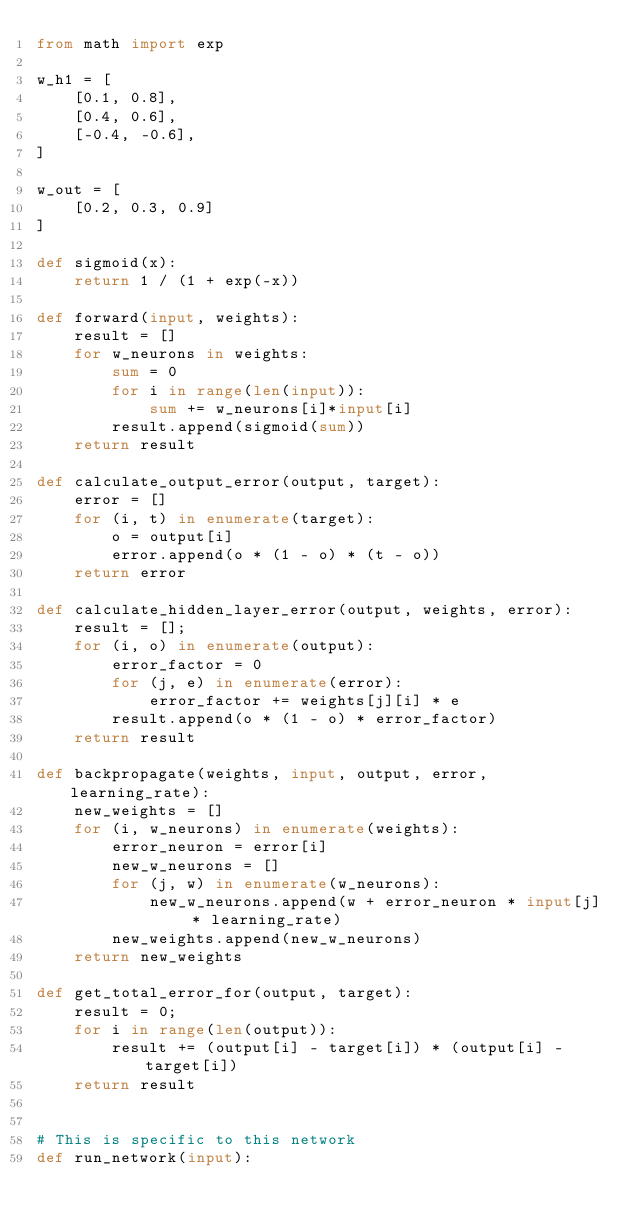Convert code to text. <code><loc_0><loc_0><loc_500><loc_500><_Python_>from math import exp

w_h1 = [
    [0.1, 0.8],
    [0.4, 0.6],
    [-0.4, -0.6],
]

w_out = [
    [0.2, 0.3, 0.9]
]

def sigmoid(x):
    return 1 / (1 + exp(-x))

def forward(input, weights):
    result = []
    for w_neurons in weights:
        sum = 0
        for i in range(len(input)):
            sum += w_neurons[i]*input[i]
        result.append(sigmoid(sum))
    return result

def calculate_output_error(output, target):
    error = []
    for (i, t) in enumerate(target):
        o = output[i]
        error.append(o * (1 - o) * (t - o))
    return error

def calculate_hidden_layer_error(output, weights, error):
    result = [];
    for (i, o) in enumerate(output):
        error_factor = 0
        for (j, e) in enumerate(error):
            error_factor += weights[j][i] * e
        result.append(o * (1 - o) * error_factor)
    return result

def backpropagate(weights, input, output, error, learning_rate):
    new_weights = []
    for (i, w_neurons) in enumerate(weights):
        error_neuron = error[i]
        new_w_neurons = []
        for (j, w) in enumerate(w_neurons):
            new_w_neurons.append(w + error_neuron * input[j] * learning_rate)
        new_weights.append(new_w_neurons)
    return new_weights

def get_total_error_for(output, target):
    result = 0;
    for i in range(len(output)):
        result += (output[i] - target[i]) * (output[i] - target[i])
    return result


# This is specific to this network
def run_network(input):</code> 